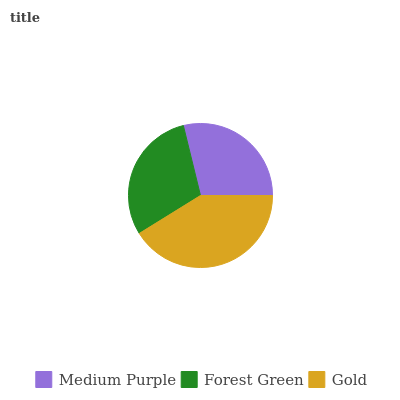Is Medium Purple the minimum?
Answer yes or no. Yes. Is Gold the maximum?
Answer yes or no. Yes. Is Forest Green the minimum?
Answer yes or no. No. Is Forest Green the maximum?
Answer yes or no. No. Is Forest Green greater than Medium Purple?
Answer yes or no. Yes. Is Medium Purple less than Forest Green?
Answer yes or no. Yes. Is Medium Purple greater than Forest Green?
Answer yes or no. No. Is Forest Green less than Medium Purple?
Answer yes or no. No. Is Forest Green the high median?
Answer yes or no. Yes. Is Forest Green the low median?
Answer yes or no. Yes. Is Gold the high median?
Answer yes or no. No. Is Gold the low median?
Answer yes or no. No. 